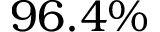<formula> <loc_0><loc_0><loc_500><loc_500>9 6 . 4 \%</formula> 